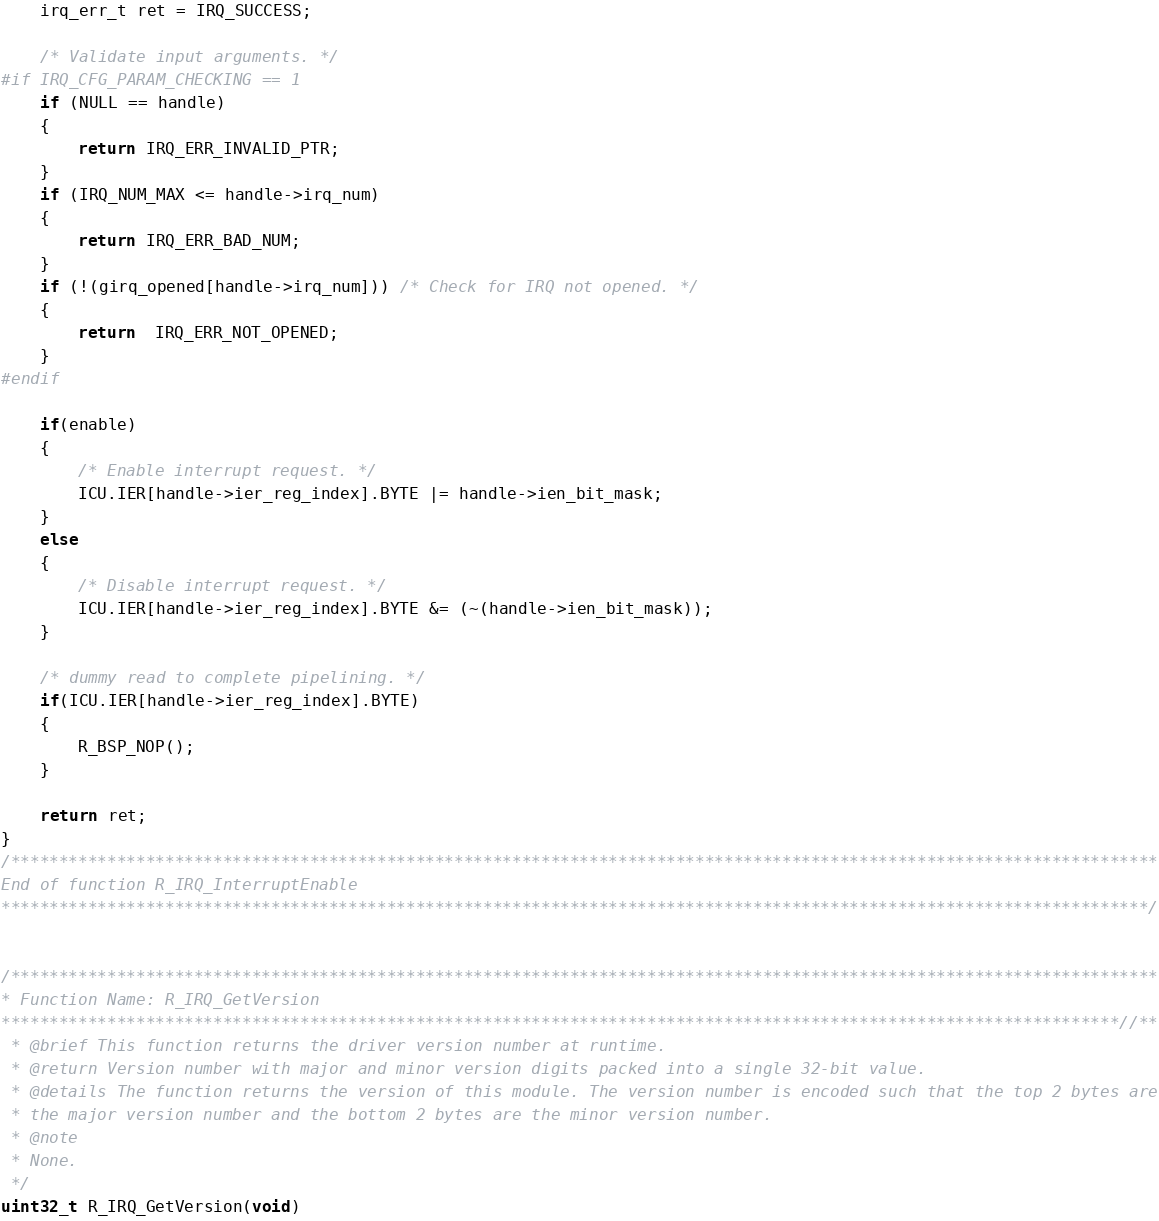<code> <loc_0><loc_0><loc_500><loc_500><_C_>    irq_err_t ret = IRQ_SUCCESS;

    /* Validate input arguments. */
#if IRQ_CFG_PARAM_CHECKING == 1
    if (NULL == handle)
    {
        return IRQ_ERR_INVALID_PTR;
    }
    if (IRQ_NUM_MAX <= handle->irq_num)
    {
        return IRQ_ERR_BAD_NUM;
    }
    if (!(girq_opened[handle->irq_num])) /* Check for IRQ not opened. */
    {
        return  IRQ_ERR_NOT_OPENED;
    }
#endif

    if(enable)
    {
        /* Enable interrupt request. */
        ICU.IER[handle->ier_reg_index].BYTE |= handle->ien_bit_mask;
    }
    else
    {
        /* Disable interrupt request. */
        ICU.IER[handle->ier_reg_index].BYTE &= (~(handle->ien_bit_mask));
    }

    /* dummy read to complete pipelining. */
    if(ICU.IER[handle->ier_reg_index].BYTE)
    {
        R_BSP_NOP();
    }

    return ret;
}
/***********************************************************************************************************************
End of function R_IRQ_InterruptEnable
***********************************************************************************************************************/


/***********************************************************************************************************************
* Function Name: R_IRQ_GetVersion
********************************************************************************************************************//**
 * @brief This function returns the driver version number at runtime.
 * @return Version number with major and minor version digits packed into a single 32-bit value.
 * @details The function returns the version of this module. The version number is encoded such that the top 2 bytes are
 * the major version number and the bottom 2 bytes are the minor version number.
 * @note
 * None.
 */
uint32_t R_IRQ_GetVersion(void)</code> 